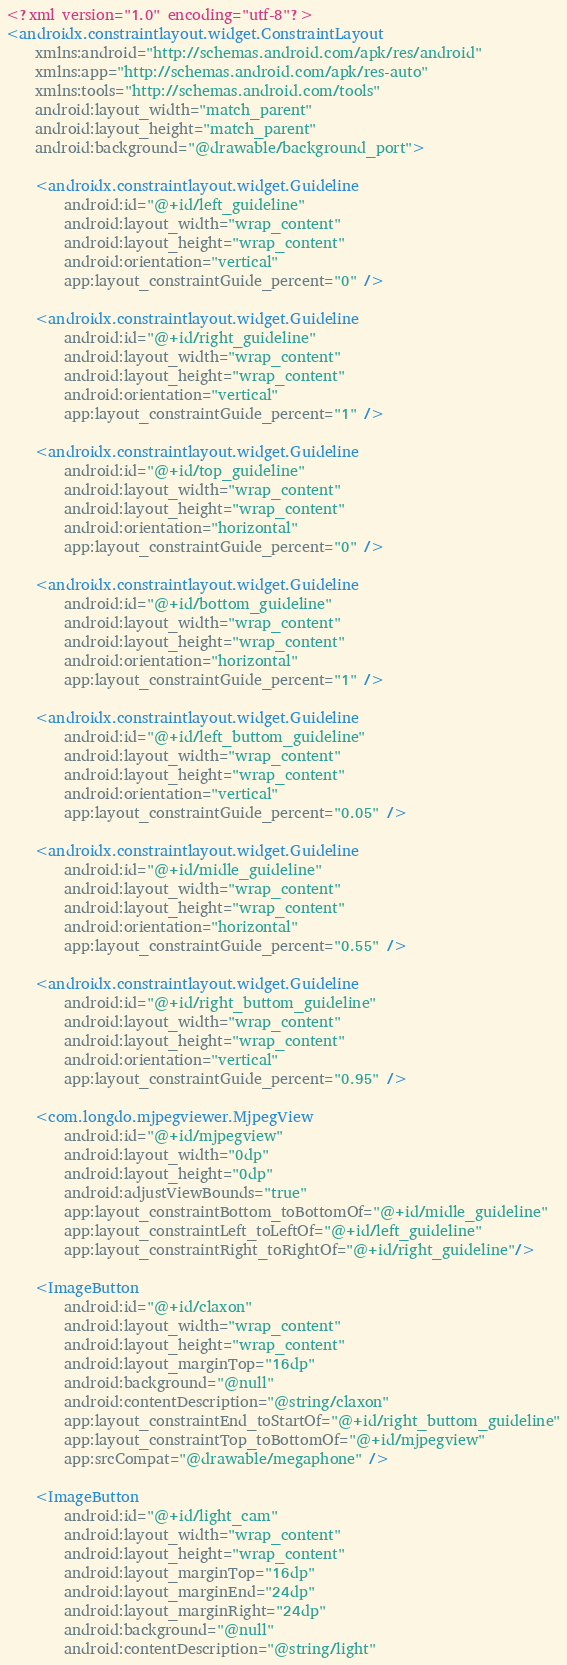<code> <loc_0><loc_0><loc_500><loc_500><_XML_><?xml version="1.0" encoding="utf-8"?>
<androidx.constraintlayout.widget.ConstraintLayout
    xmlns:android="http://schemas.android.com/apk/res/android"
    xmlns:app="http://schemas.android.com/apk/res-auto"
    xmlns:tools="http://schemas.android.com/tools"
    android:layout_width="match_parent"
    android:layout_height="match_parent"
    android:background="@drawable/background_port">

    <androidx.constraintlayout.widget.Guideline
        android:id="@+id/left_guideline"
        android:layout_width="wrap_content"
        android:layout_height="wrap_content"
        android:orientation="vertical"
        app:layout_constraintGuide_percent="0" />

    <androidx.constraintlayout.widget.Guideline
        android:id="@+id/right_guideline"
        android:layout_width="wrap_content"
        android:layout_height="wrap_content"
        android:orientation="vertical"
        app:layout_constraintGuide_percent="1" />

    <androidx.constraintlayout.widget.Guideline
        android:id="@+id/top_guideline"
        android:layout_width="wrap_content"
        android:layout_height="wrap_content"
        android:orientation="horizontal"
        app:layout_constraintGuide_percent="0" />

    <androidx.constraintlayout.widget.Guideline
        android:id="@+id/bottom_guideline"
        android:layout_width="wrap_content"
        android:layout_height="wrap_content"
        android:orientation="horizontal"
        app:layout_constraintGuide_percent="1" />

    <androidx.constraintlayout.widget.Guideline
        android:id="@+id/left_buttom_guideline"
        android:layout_width="wrap_content"
        android:layout_height="wrap_content"
        android:orientation="vertical"
        app:layout_constraintGuide_percent="0.05" />

    <androidx.constraintlayout.widget.Guideline
        android:id="@+id/midle_guideline"
        android:layout_width="wrap_content"
        android:layout_height="wrap_content"
        android:orientation="horizontal"
        app:layout_constraintGuide_percent="0.55" />

    <androidx.constraintlayout.widget.Guideline
        android:id="@+id/right_buttom_guideline"
        android:layout_width="wrap_content"
        android:layout_height="wrap_content"
        android:orientation="vertical"
        app:layout_constraintGuide_percent="0.95" />

    <com.longdo.mjpegviewer.MjpegView
        android:id="@+id/mjpegview"
        android:layout_width="0dp"
        android:layout_height="0dp"
        android:adjustViewBounds="true"
        app:layout_constraintBottom_toBottomOf="@+id/midle_guideline"
        app:layout_constraintLeft_toLeftOf="@+id/left_guideline"
        app:layout_constraintRight_toRightOf="@+id/right_guideline"/>

    <ImageButton
        android:id="@+id/claxon"
        android:layout_width="wrap_content"
        android:layout_height="wrap_content"
        android:layout_marginTop="16dp"
        android:background="@null"
        android:contentDescription="@string/claxon"
        app:layout_constraintEnd_toStartOf="@+id/right_buttom_guideline"
        app:layout_constraintTop_toBottomOf="@+id/mjpegview"
        app:srcCompat="@drawable/megaphone" />

    <ImageButton
        android:id="@+id/light_cam"
        android:layout_width="wrap_content"
        android:layout_height="wrap_content"
        android:layout_marginTop="16dp"
        android:layout_marginEnd="24dp"
        android:layout_marginRight="24dp"
        android:background="@null"
        android:contentDescription="@string/light"</code> 